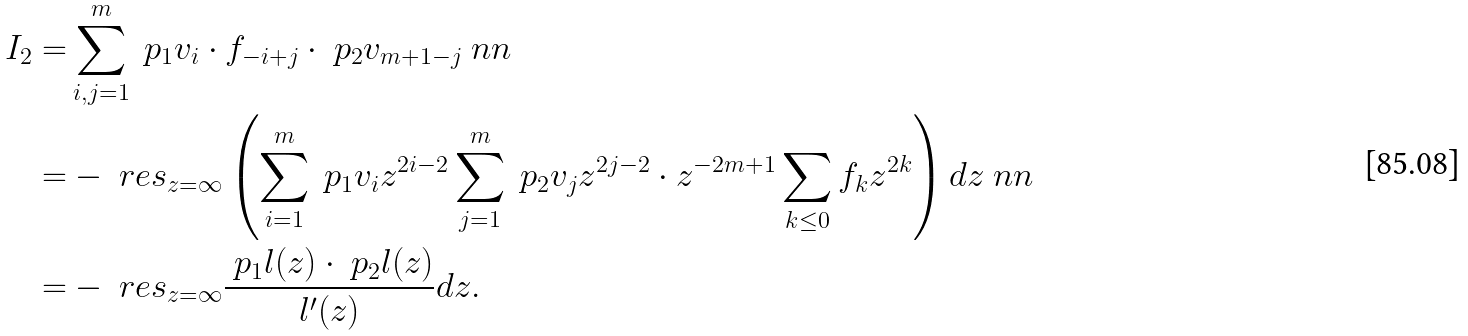<formula> <loc_0><loc_0><loc_500><loc_500>I _ { 2 } = & \sum _ { i , j = 1 } ^ { m } \ p _ { 1 } v _ { i } \cdot f _ { - i + j } \cdot \ p _ { 2 } v _ { m + 1 - j } \ n n \\ = & - \ r e s _ { z = \infty } \left ( \sum _ { i = 1 } ^ { m } \ p _ { 1 } v _ { i } z ^ { 2 i - 2 } \sum _ { j = 1 } ^ { m } \ p _ { 2 } v _ { j } z ^ { 2 j - 2 } \cdot z ^ { - 2 m + 1 } \sum _ { k \leq 0 } f _ { k } z ^ { 2 k } \right ) d z \ n n \\ = & - \ r e s _ { z = \infty } \frac { \ p _ { 1 } l ( z ) \cdot \ p _ { 2 } l ( z ) } { l ^ { \prime } ( z ) } d z .</formula> 